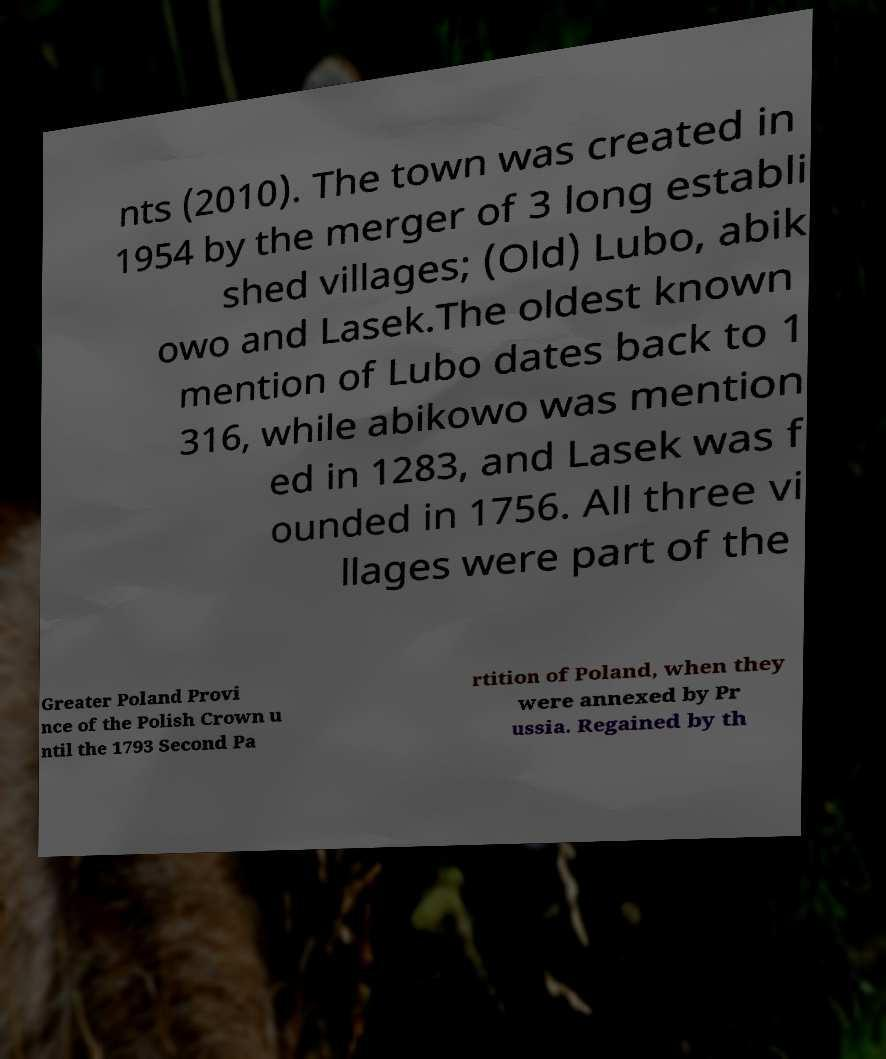I need the written content from this picture converted into text. Can you do that? nts (2010). The town was created in 1954 by the merger of 3 long establi shed villages; (Old) Lubo, abik owo and Lasek.The oldest known mention of Lubo dates back to 1 316, while abikowo was mention ed in 1283, and Lasek was f ounded in 1756. All three vi llages were part of the Greater Poland Provi nce of the Polish Crown u ntil the 1793 Second Pa rtition of Poland, when they were annexed by Pr ussia. Regained by th 